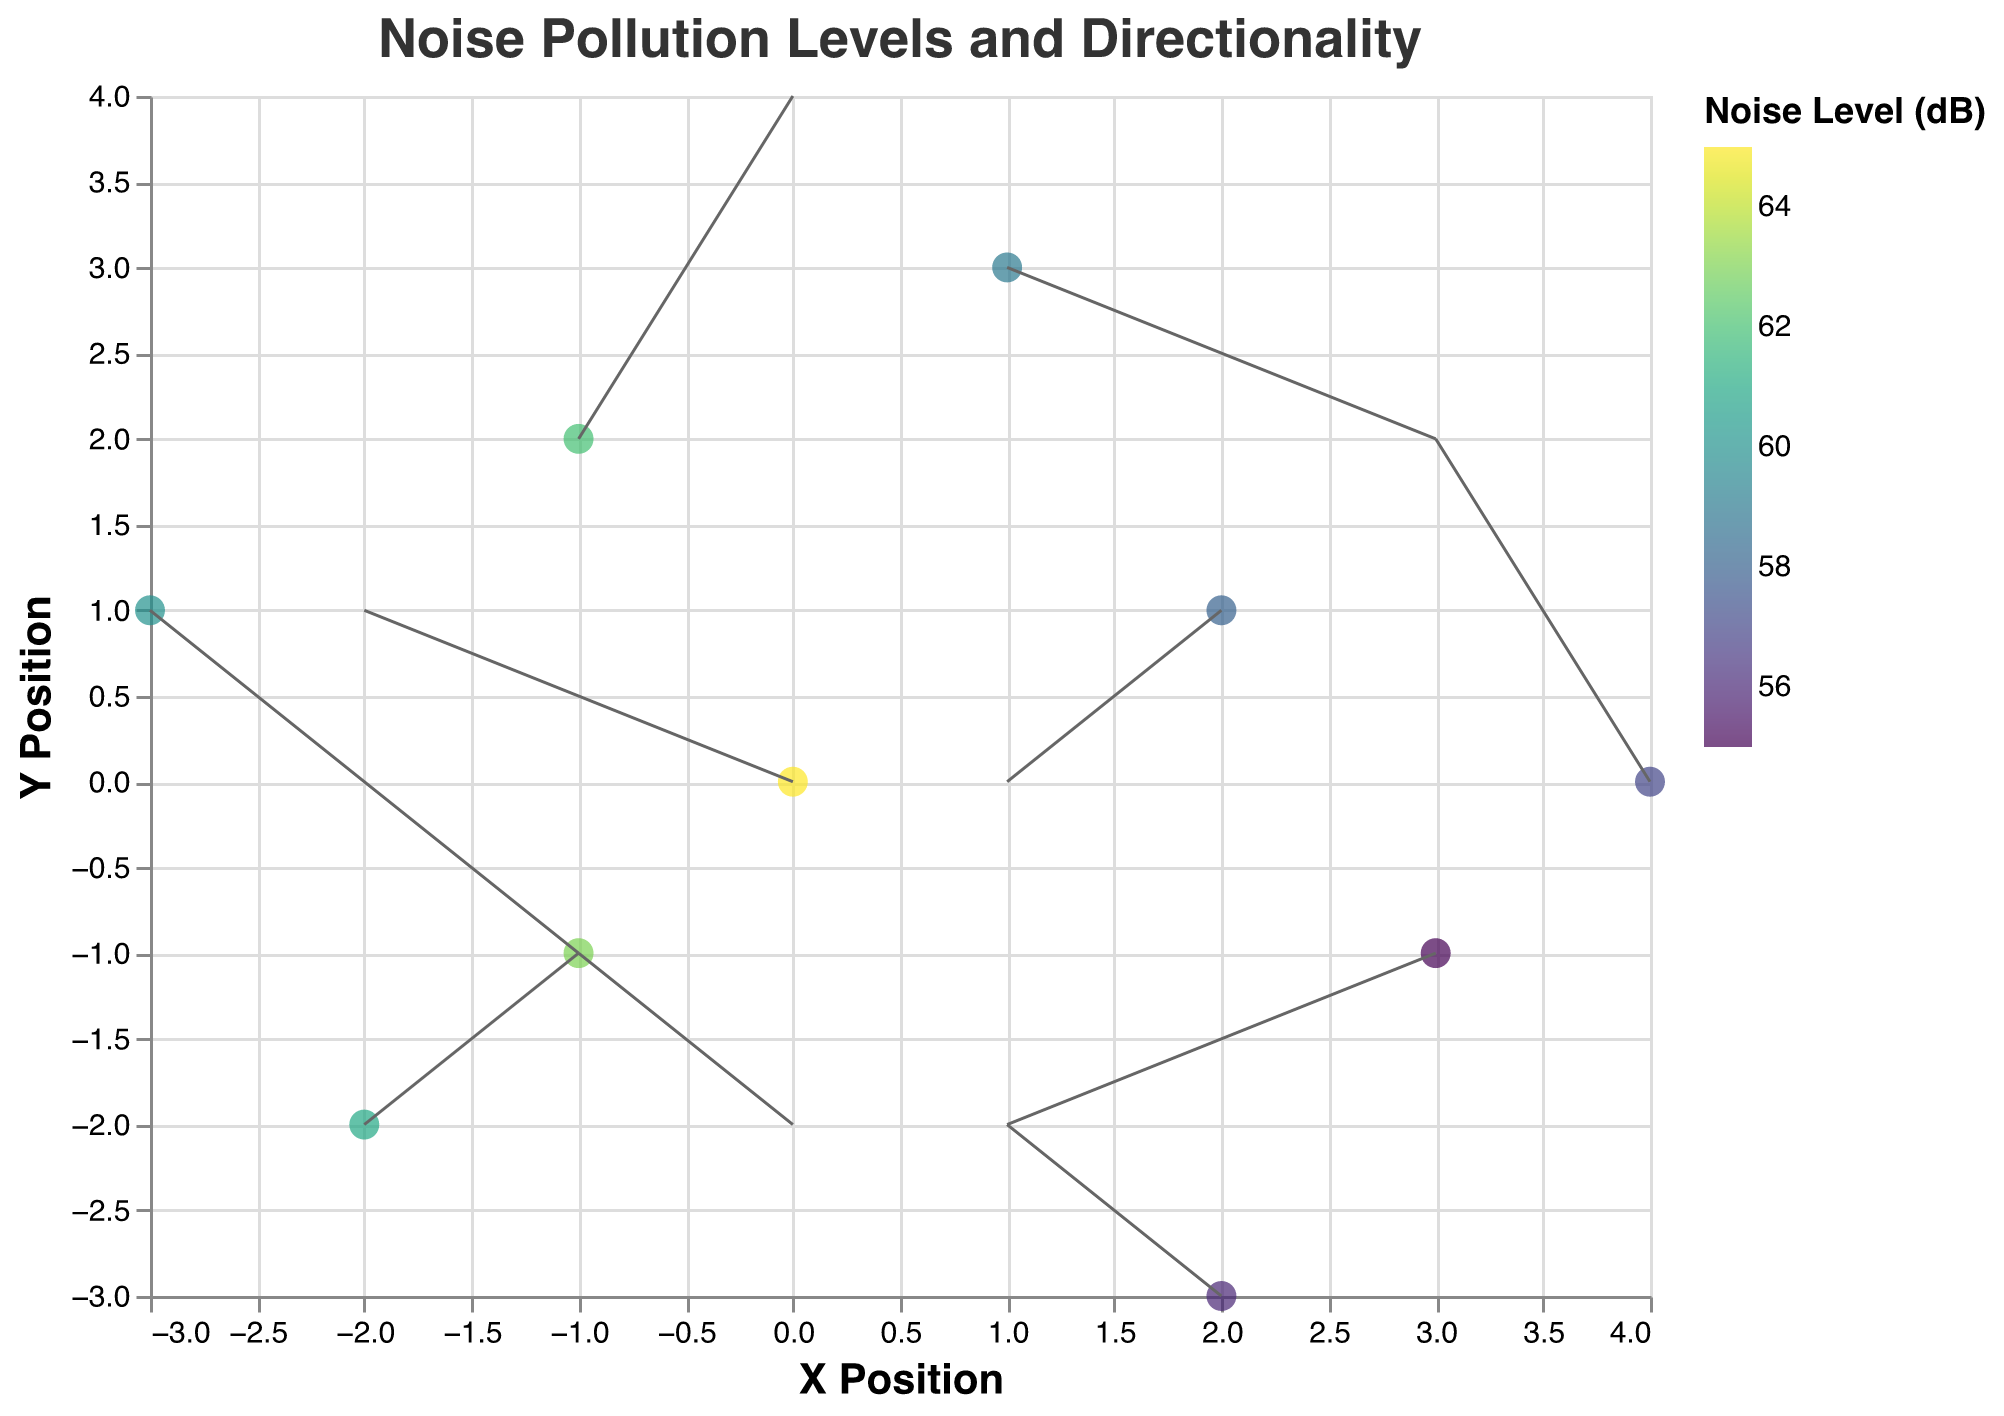How many data points represent noise sources affecting the child's sleep? By looking at the number of marks in the plot, each representing a noise source, we can count the displayed data points.
Answer: 10 Which noise source has the highest noise level and what is its magnitude? By examining the color intensity in the plot and referencing the tooltip for the magnitude of noise level, we can identify the highest value. The tooltip for "Interstate 95" shows the highest magnitude of 65 dB.
Answer: Interstate 95, 65 dB What is the directionality of noise emerging from "Construction Site A"? Locate "Construction Site A" on the plot and observe the direction indicated by the corresponding arrow. The u and v values show the vector direction. For "Construction Site A," the direction is (1, 2).
Answer: (1, 2) What can be inferred about the noise directionality and level at location (x=1, y=3)? Locate the data point at (x=1, y=3) in the plot. The tooltip shows "Highway 101" with a noise level of 59 dB. Its direction vector (u, v) is (2, -1), indicating the direction of noise.
Answer: Highway 101, 59 dB, (2, -1) Which noise source has the lowest magnitude and what is its directionality? Identify the point with the least color intensity in the legend and plot, representing the lowest dB value. The tooltip for "Residential Road" shows the lowest magnitude of 55 dB. The direction is given by the vector (-2, -1).
Answer: Residential Road, 55 dB, (-2, -1) List all noise sources that have a magnitude greater than 60. By accessing the legend and tooltip information for all data points, identify those with a magnitude above 60 dB: "Interstate 95" (65 dB), "Construction Site A" (62 dB), "Construction Site B" (61 dB), "Train Station" (63 dB).
Answer: Interstate 95, Construction Site A, Construction Site B, Train Station What are the noise levels and directions for sources at negative x positions? Identify sources at x < 0 on the plot and use tooltips to check their magnitude and direction: (x=-1, y=2), "Construction Site A" (62 dB, (1, 2)); (x=-1, y=-1), "Train Station" (63 dB, (1, -1)); (x=-2, y=-2), "Construction Site B" (61 dB, (1, 1)); (x=-3, y=1), "Shopping Center" (60 dB, (2, -2)).
Answer: Construction Site A: 62 dB, (1, 2); Train Station: 63 dB, (1, -1); Construction Site B: 61 dB, (1, 1); Shopping Center: 60 dB, (2, -2) Which source is closest to the origin and what is its noise level? Locate the data point nearest to (0,0) in the plot. "Interstate 95" at (0, 0) is closest with a noise level of 65 dB.
Answer: Interstate 95, 65 dB 